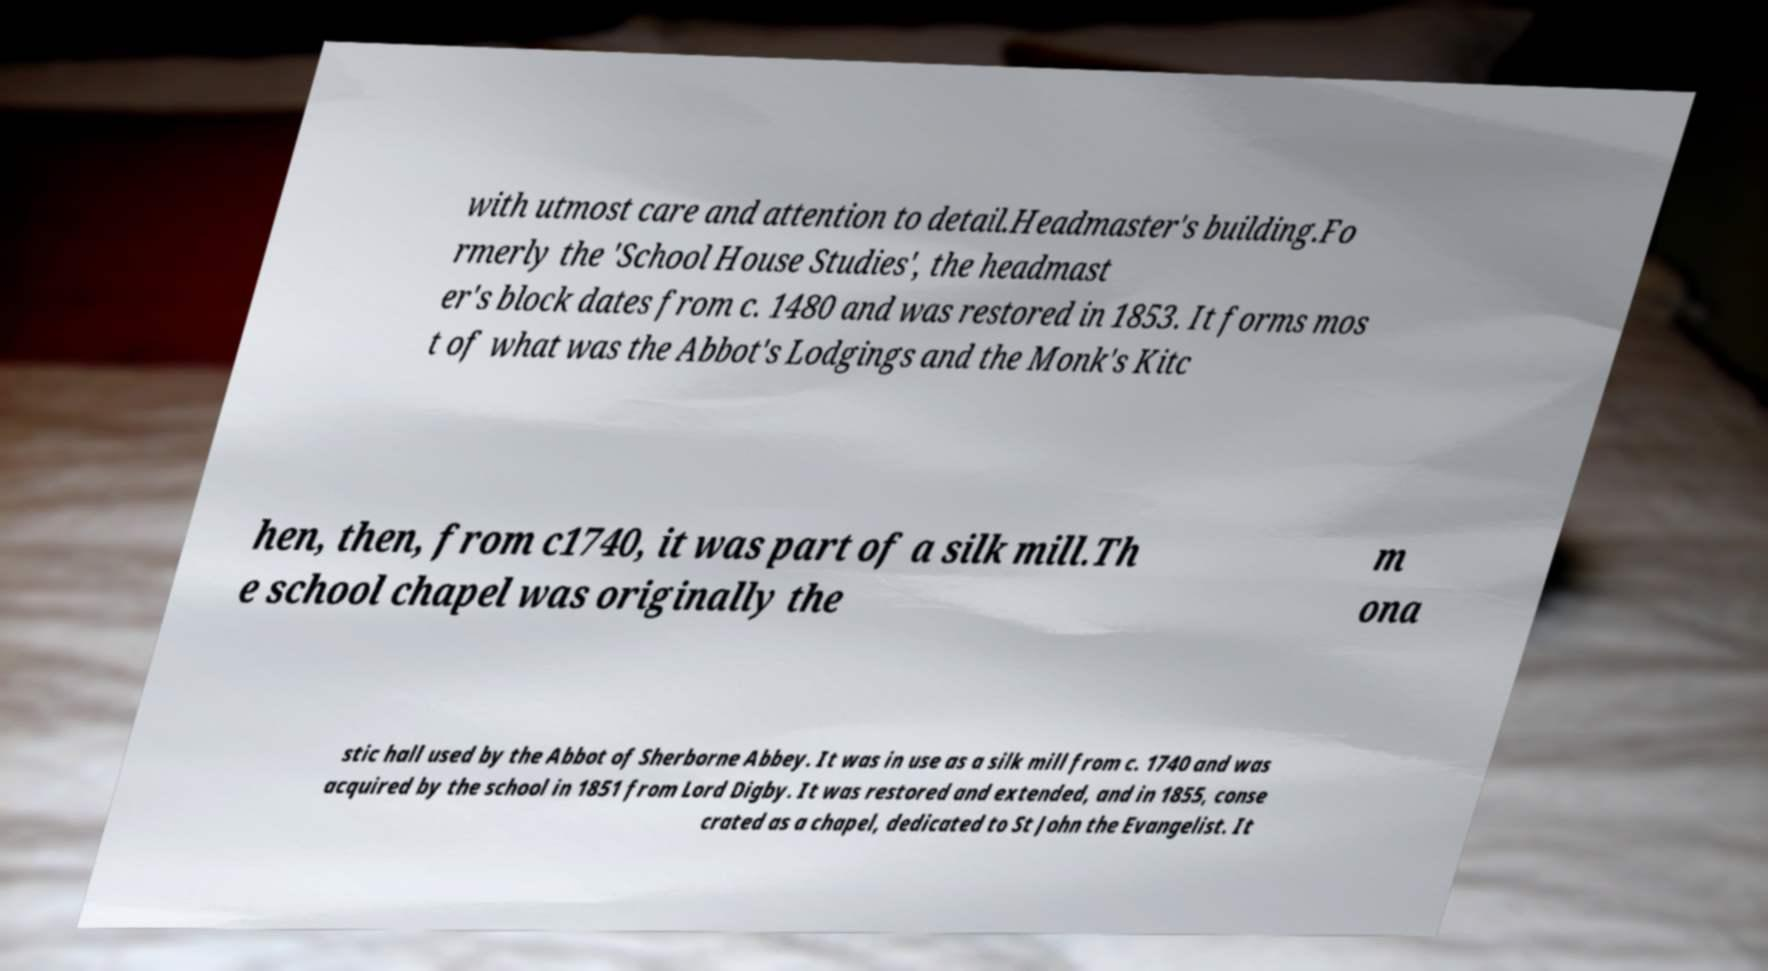There's text embedded in this image that I need extracted. Can you transcribe it verbatim? with utmost care and attention to detail.Headmaster's building.Fo rmerly the 'School House Studies', the headmast er's block dates from c. 1480 and was restored in 1853. It forms mos t of what was the Abbot's Lodgings and the Monk's Kitc hen, then, from c1740, it was part of a silk mill.Th e school chapel was originally the m ona stic hall used by the Abbot of Sherborne Abbey. It was in use as a silk mill from c. 1740 and was acquired by the school in 1851 from Lord Digby. It was restored and extended, and in 1855, conse crated as a chapel, dedicated to St John the Evangelist. It 